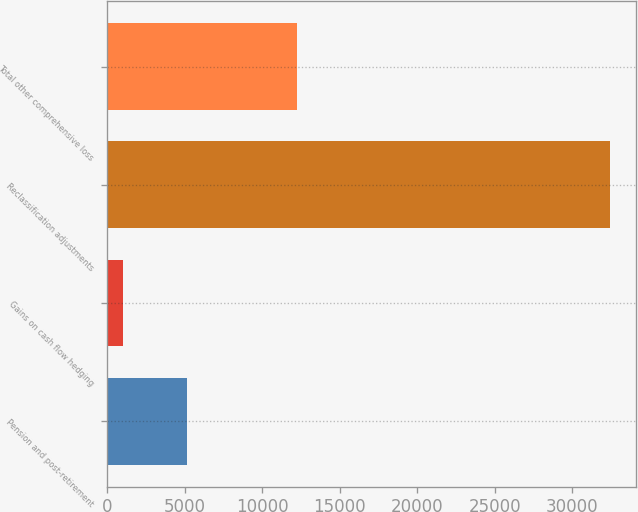<chart> <loc_0><loc_0><loc_500><loc_500><bar_chart><fcel>Pension and post-retirement<fcel>Gains on cash flow hedging<fcel>Reclassification adjustments<fcel>Total other comprehensive loss<nl><fcel>5130<fcel>1001<fcel>32477<fcel>12223<nl></chart> 